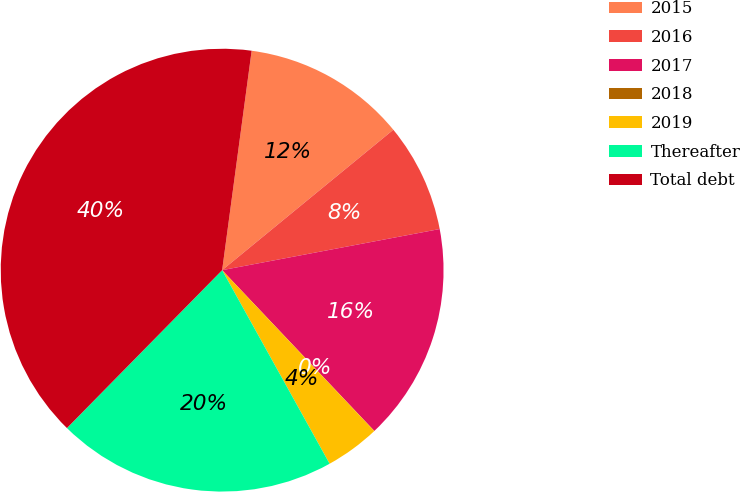<chart> <loc_0><loc_0><loc_500><loc_500><pie_chart><fcel>2015<fcel>2016<fcel>2017<fcel>2018<fcel>2019<fcel>Thereafter<fcel>Total debt<nl><fcel>11.94%<fcel>7.96%<fcel>15.91%<fcel>0.01%<fcel>3.99%<fcel>20.43%<fcel>39.77%<nl></chart> 